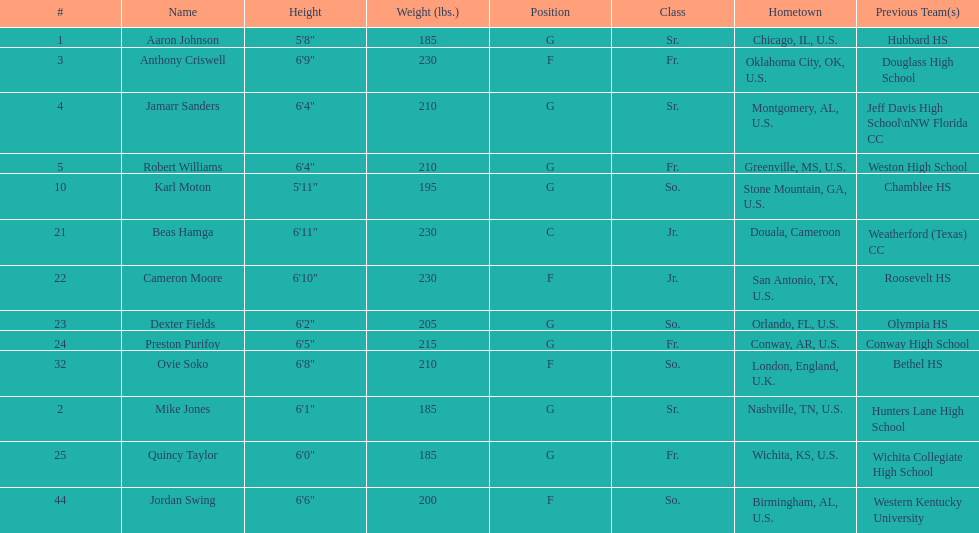Who weighs more, dexter fields or ovie soko? Ovie Soko. 